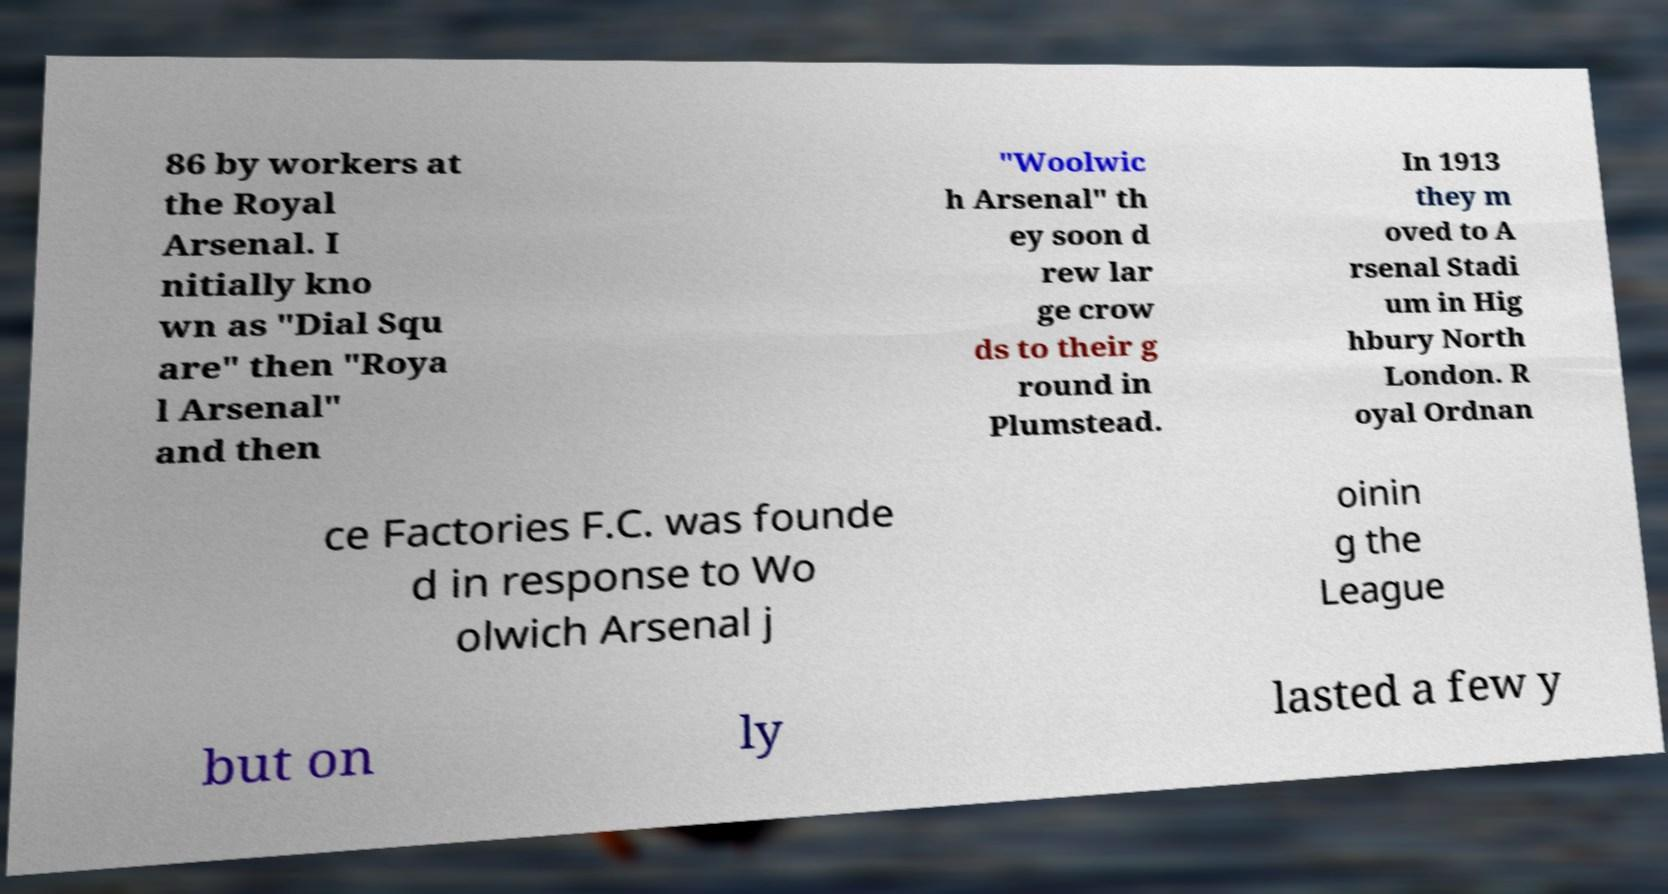Can you accurately transcribe the text from the provided image for me? 86 by workers at the Royal Arsenal. I nitially kno wn as "Dial Squ are" then "Roya l Arsenal" and then "Woolwic h Arsenal" th ey soon d rew lar ge crow ds to their g round in Plumstead. In 1913 they m oved to A rsenal Stadi um in Hig hbury North London. R oyal Ordnan ce Factories F.C. was founde d in response to Wo olwich Arsenal j oinin g the League but on ly lasted a few y 